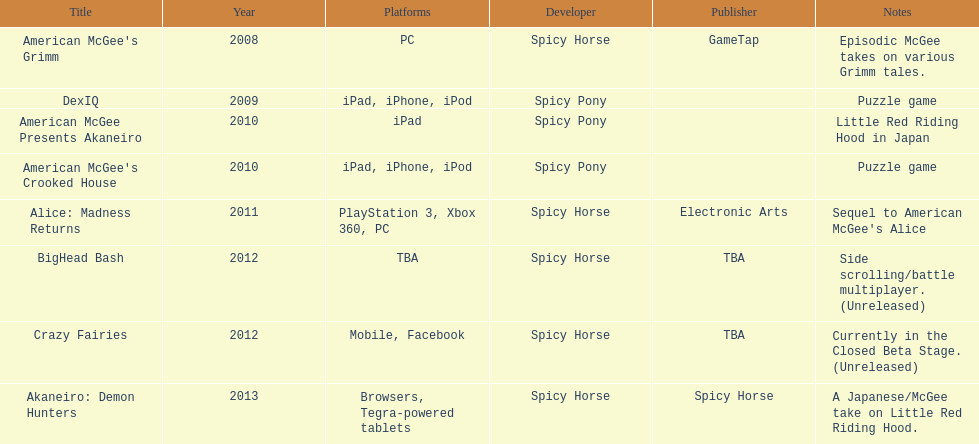What is the first title on this chart? American McGee's Grimm. 